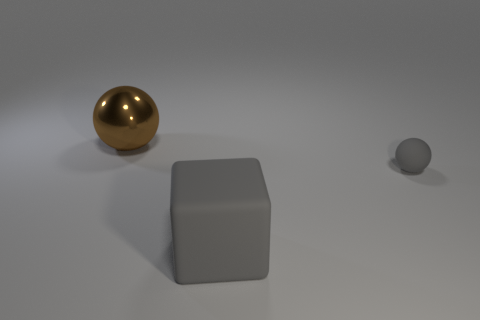Are there an equal number of large rubber cubes that are behind the big gray matte thing and large brown things?
Offer a terse response. No. Is there a big brown metal object that is in front of the ball in front of the metallic object?
Provide a succinct answer. No. How many other objects are there of the same color as the big shiny sphere?
Your answer should be compact. 0. The rubber block is what color?
Your answer should be compact. Gray. There is a thing that is to the right of the brown metal object and behind the large gray matte cube; how big is it?
Make the answer very short. Small. What number of things are balls that are behind the matte sphere or green metallic cylinders?
Make the answer very short. 1. There is a small gray thing that is made of the same material as the big gray thing; what shape is it?
Your answer should be compact. Sphere. The tiny rubber thing has what shape?
Your response must be concise. Sphere. There is a object that is to the right of the brown metallic thing and behind the big matte object; what is its color?
Your answer should be compact. Gray. There is a brown thing that is the same size as the gray matte cube; what shape is it?
Provide a short and direct response. Sphere. 